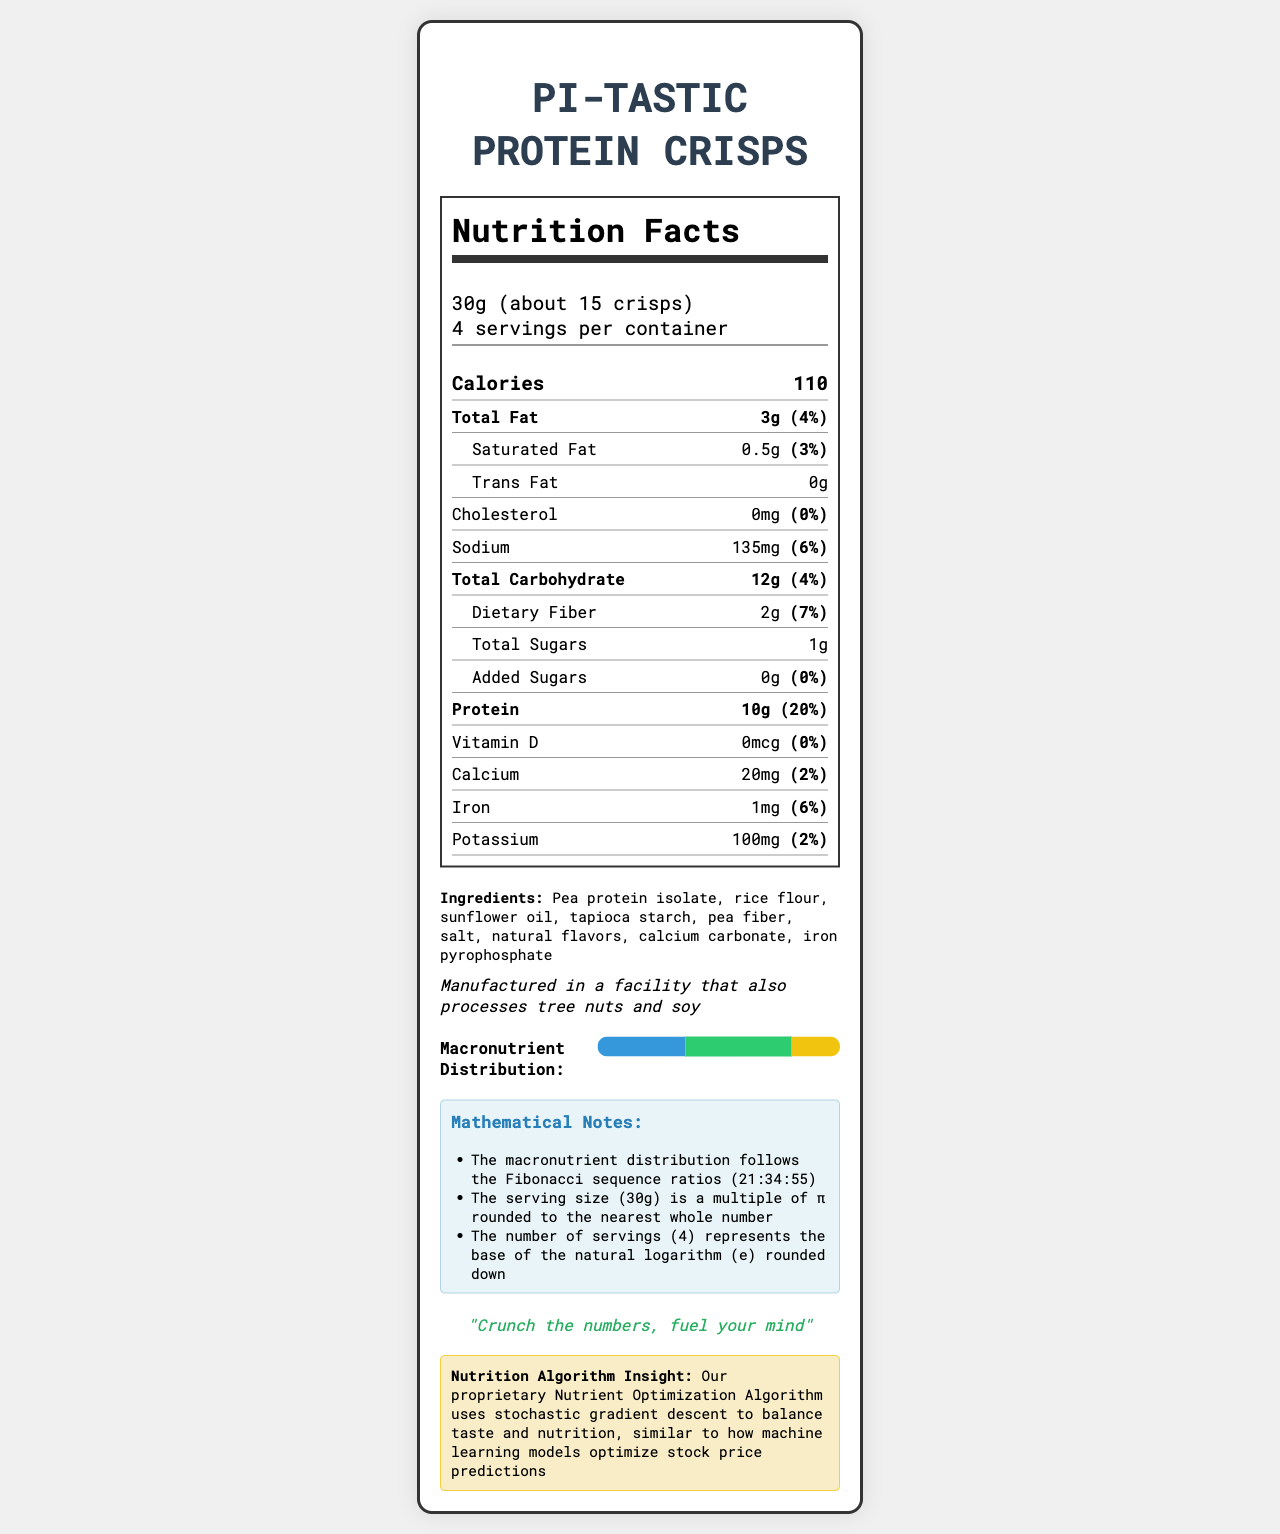what is the serving size? The serving size is explicitly mentioned in the document as "30g (about 15 crisps)".
Answer: 30g (about 15 crisps) how many servings are in one container? The document states that there are 4 servings per container.
Answer: 4 what is the total fat content per serving? The total fat content per serving is listed as "3g".
Answer: 3g what percentage of the daily value does the protein content per serving represent? The document indicates the percent daily value for protein is 20%.
Answer: 20% what is the amount of dietary fiber per serving? The amount of dietary fiber per serving is explicitly specified as "2g".
Answer: 2g What are the three main ingredients in the crisps? A. Pea protein isolate, rice flour, sunflower oil B. Pea protein isolate, salt, calcium carbonate C. Pea fiber, tapioca starch, sunflower oil D. Salt, sunflower oil, natural flavors The first three ingredients listed in the document's ingredient section are "Pea protein isolate, rice flour, sunflower oil".
Answer: A What is the total amount of sugars per serving? A. 0g B. 1g C. 2g D. 3g The nutrition label lists the total sugars per serving as "1g".
Answer: B Is there any cholesterol in the Pi-tastic Protein Crisps per serving? The document states that there is 0mg of cholesterol, which implies there is no cholesterol per serving.
Answer: No Summarize the main nutritional highlights of the Pi-tastic Protein Crisps. This summary includes the key nutritional components, macronutrient distribution, and special insights from the document.
Answer: The Pi-tastic Protein Crisps have a serving size of 30g (about 15 crisps) and contain 110 calories per serving. They are a low-fat snack with 3g total fat, 0.5g saturated fat, and 0g trans fat. Each serving provides 10g of protein and 12g of carbohydrates, including 2g of dietary fiber and 1g of sugars. They have no cholesterol and moderate sodium content (135mg). The macronutrient distribution shows 36.36% protein, 43.64% carbohydrates, and 20% fat, with nutritional insights linked to specific mathematical models and algorithms. What specific allergens are mentioned in the allergen information section? The allergen information section states that the product is manufactured in a facility that processes tree nuts and soy.
Answer: Tree nuts and soy Is the potassium content significant compared to the daily value? The potassium content per serving is 100mg, which is only 2% of the daily value, indicating it is not a significant source.
Answer: No What does the mathematical note about the serving size suggest? The document mentions that the serving size is chosen to be a multiple of π, rounded to the nearest whole number.
Answer: The serving size (30g) is a multiple of π rounded to the nearest whole number What is the nutrition algorithm insight mentioned in the document? The insight provided is that a sophisticated algorithm using stochastic gradient descent is used for balancing taste and nutrition.
Answer: The Nutrition Optimization Algorithm uses stochastic gradient descent to balance taste and nutrition, similar to optimizing stock price predictions How much of the macronutrient distribution is allocated to fats? The document shows that the fat portion of the macronutrient distribution is 20%.
Answer: 20% What is the brand slogan of the Pi-tastic Protein Crisps? The brand slogan is written explicitly in the document.
Answer: "Crunch the numbers, fuel your mind" What are the exact values of Vitamin D and its daily percentage value per serving? The document states Vitamin D content as 0mcg per serving and its percent daily value as 0%.
Answer: 0mcg, 0% How does the fiber content compare to the daily value percentage? The dietary fiber content per serving is 2g, which represents 7% of the daily value.
Answer: 2g of dietary fiber provides 7% of the daily value What ingredient is NOT listed in the document? A. Calcium Carbonate B. Iron Pyrophosphate C. Maltodextrin The ingredients list includes calcium carbonate and iron pyrophosphate but does not mention maltodextrin.
Answer: C Can we determine the exact algorithm used for optimizing the nutrient content? Although the document states that a stochastic gradient descent algorithm is used, it does not provide further specifics on the algorithm itself.
Answer: Not enough information 